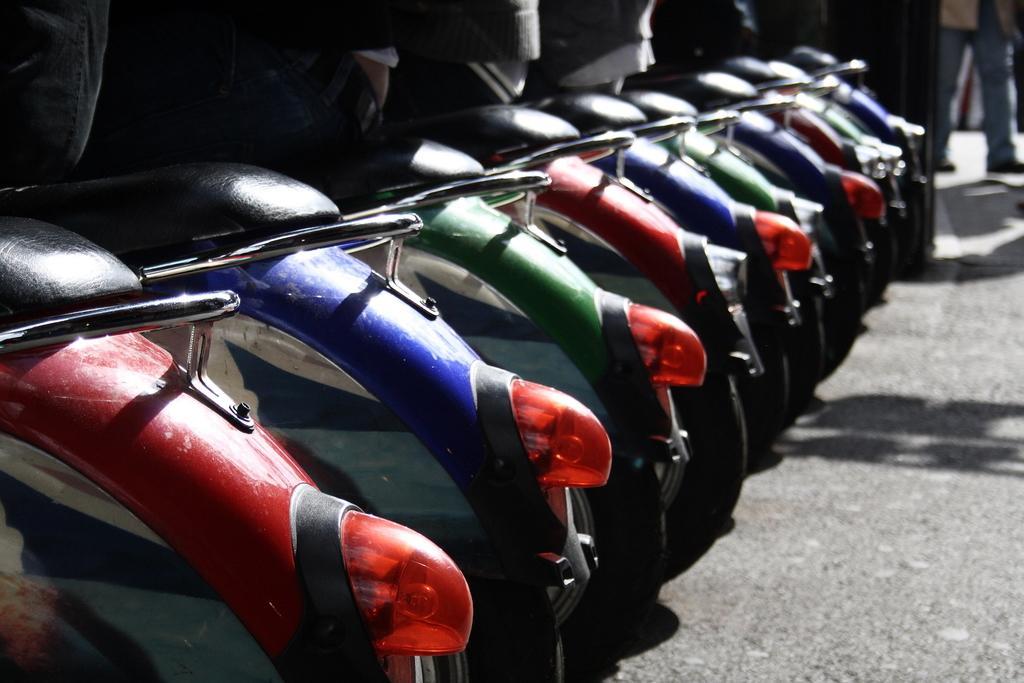How would you summarize this image in a sentence or two? We can see bikes on the road. In the background there is a person. 